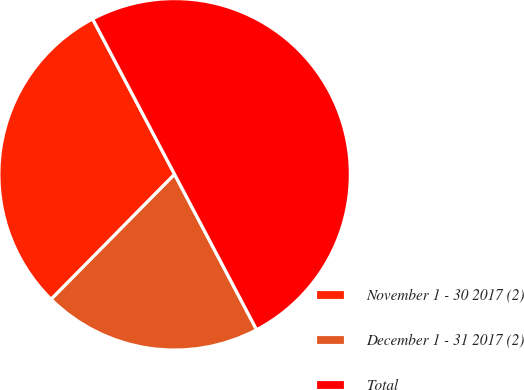Convert chart to OTSL. <chart><loc_0><loc_0><loc_500><loc_500><pie_chart><fcel>November 1 - 30 2017 (2)<fcel>December 1 - 31 2017 (2)<fcel>Total<nl><fcel>29.87%<fcel>20.13%<fcel>50.0%<nl></chart> 